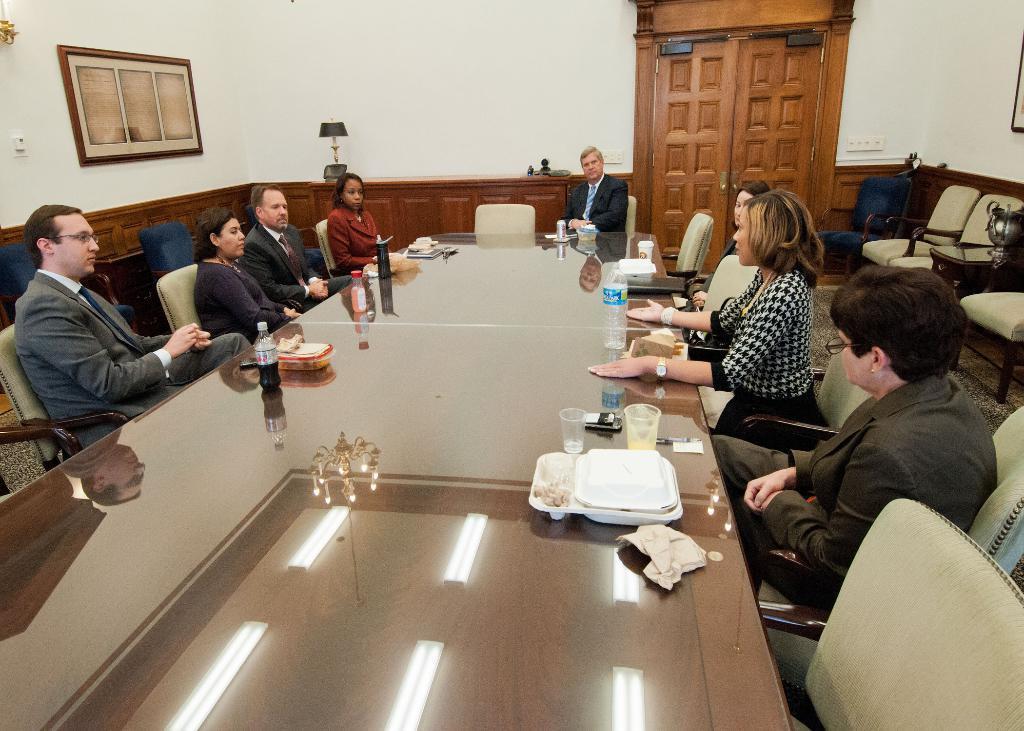Can you describe this image briefly? In this picture we can see some persons sitting on the chairs. These are the chairs. And there is a table. On the table we can see the reflection of a light. And on the table there is a bottle, glass, and a box. This is the wall and there is a frame. Here we can see a lamp. And this is the door. 